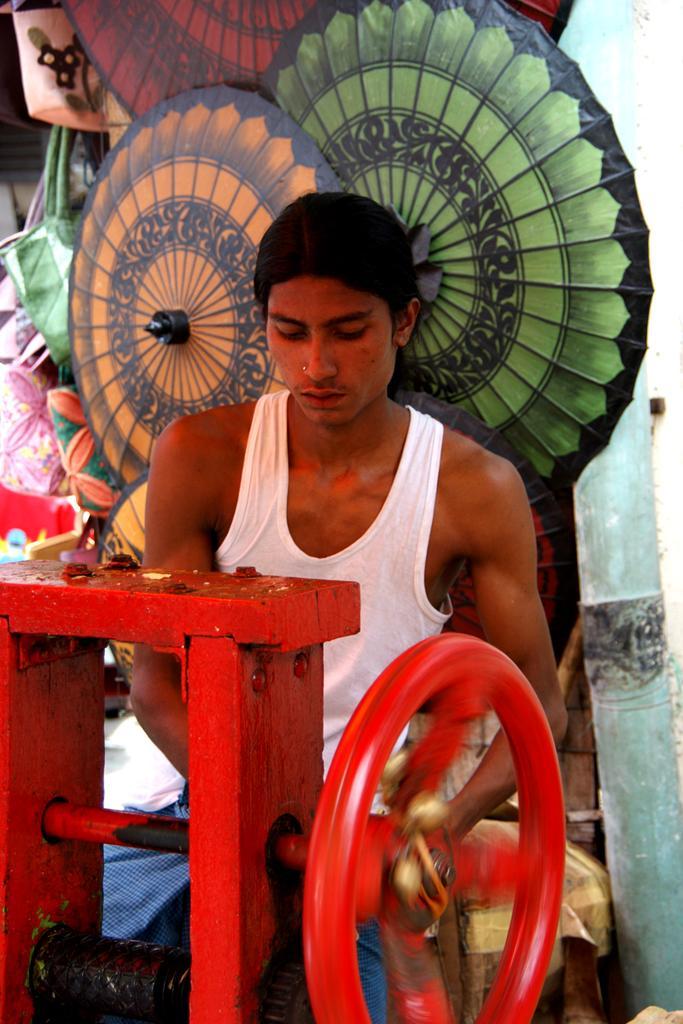Could you give a brief overview of what you see in this image? At the bottom we can see a machine and it has a wheel. In the background we can see a person,bags,objects and wall. 